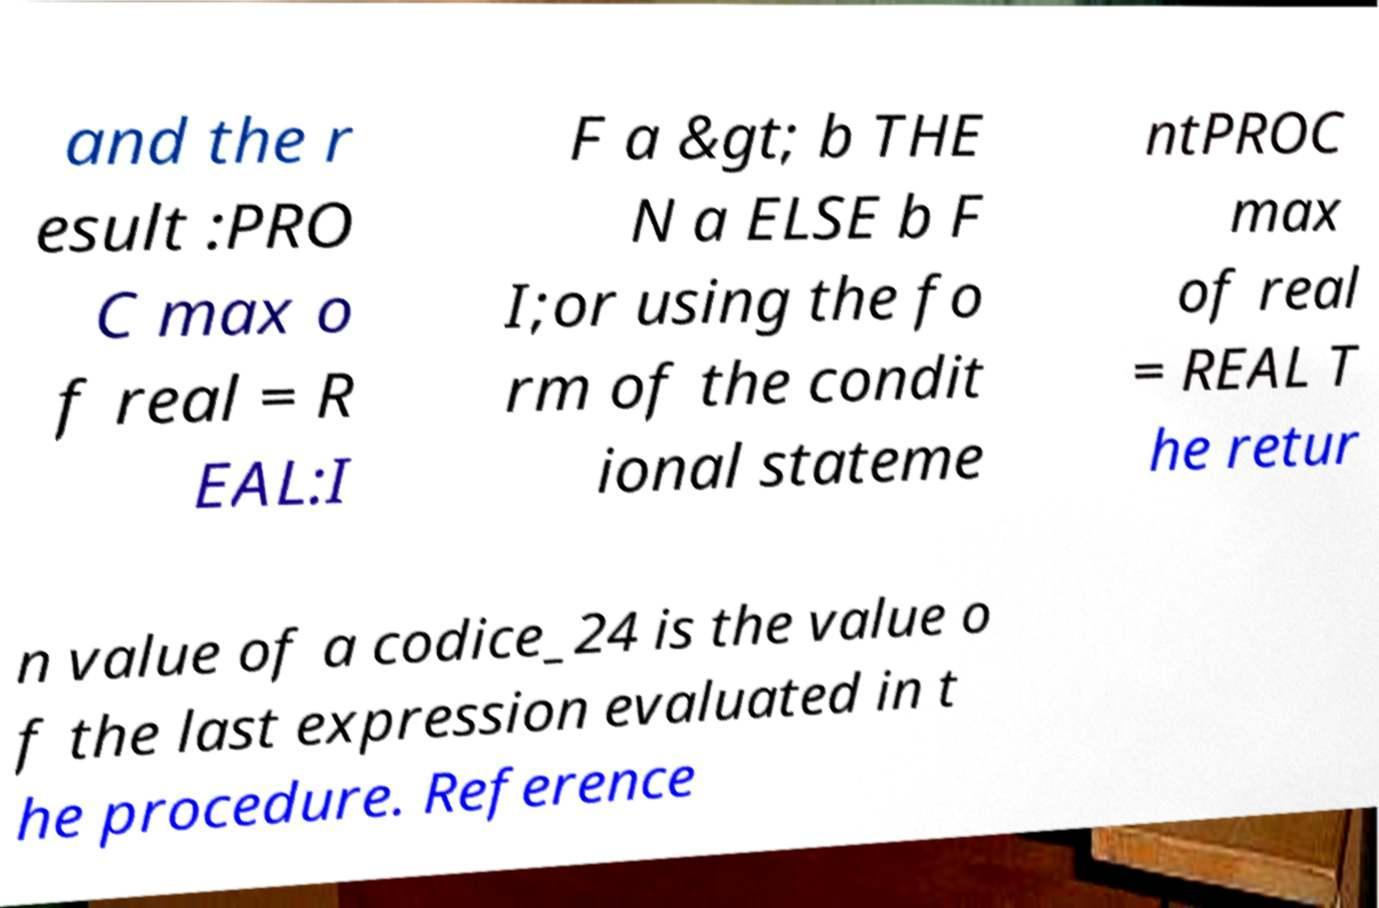There's text embedded in this image that I need extracted. Can you transcribe it verbatim? and the r esult :PRO C max o f real = R EAL:I F a &gt; b THE N a ELSE b F I;or using the fo rm of the condit ional stateme ntPROC max of real = REAL T he retur n value of a codice_24 is the value o f the last expression evaluated in t he procedure. Reference 